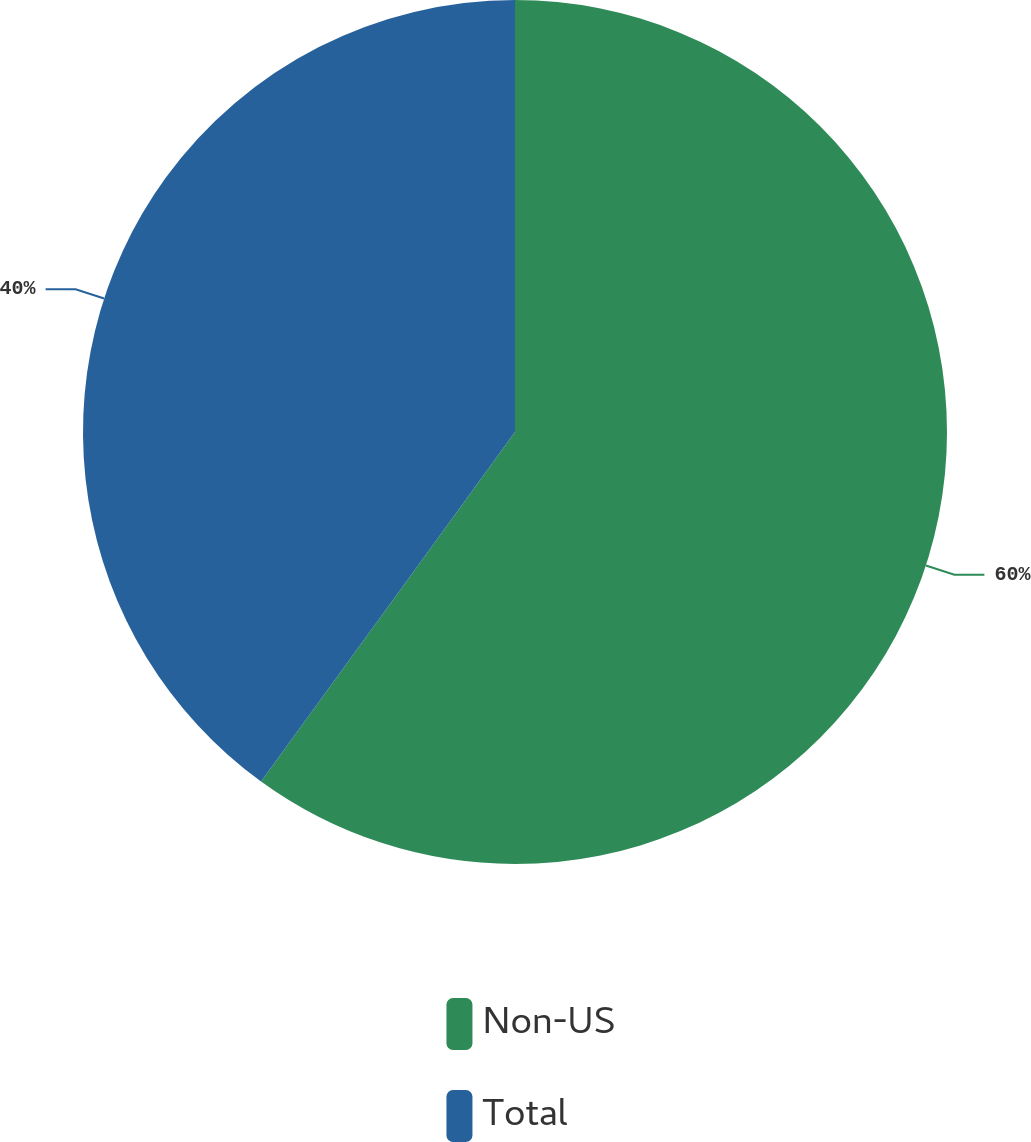Convert chart to OTSL. <chart><loc_0><loc_0><loc_500><loc_500><pie_chart><fcel>Non-US<fcel>Total<nl><fcel>60.0%<fcel>40.0%<nl></chart> 